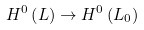Convert formula to latex. <formula><loc_0><loc_0><loc_500><loc_500>H ^ { 0 } \left ( L \right ) \rightarrow H ^ { 0 } \left ( L _ { 0 } \right )</formula> 